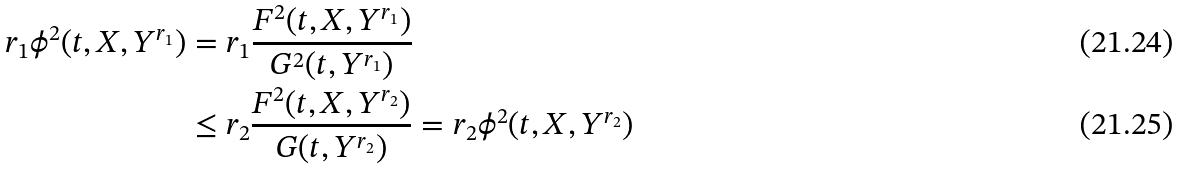<formula> <loc_0><loc_0><loc_500><loc_500>r _ { 1 } \phi ^ { 2 } ( t , X , Y ^ { r _ { 1 } } ) & = r _ { 1 } \frac { F ^ { 2 } ( t , X , Y ^ { r _ { 1 } } ) } { G ^ { 2 } ( t , Y ^ { r _ { 1 } } ) } \\ & \leq r _ { 2 } \frac { F ^ { 2 } ( t , X , Y ^ { r _ { 2 } } ) } { G ( t , Y ^ { r _ { 2 } } ) } = r _ { 2 } \phi ^ { 2 } ( t , X , Y ^ { r _ { 2 } } )</formula> 